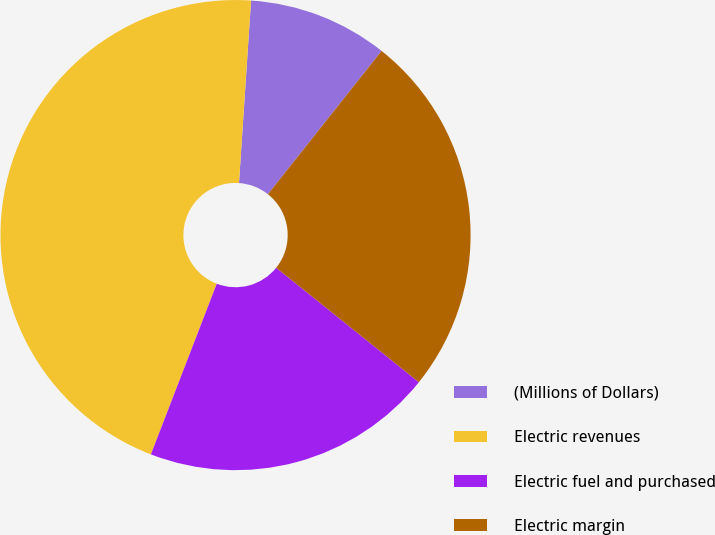Convert chart. <chart><loc_0><loc_0><loc_500><loc_500><pie_chart><fcel>(Millions of Dollars)<fcel>Electric revenues<fcel>Electric fuel and purchased<fcel>Electric margin<nl><fcel>9.62%<fcel>45.19%<fcel>20.1%<fcel>25.09%<nl></chart> 